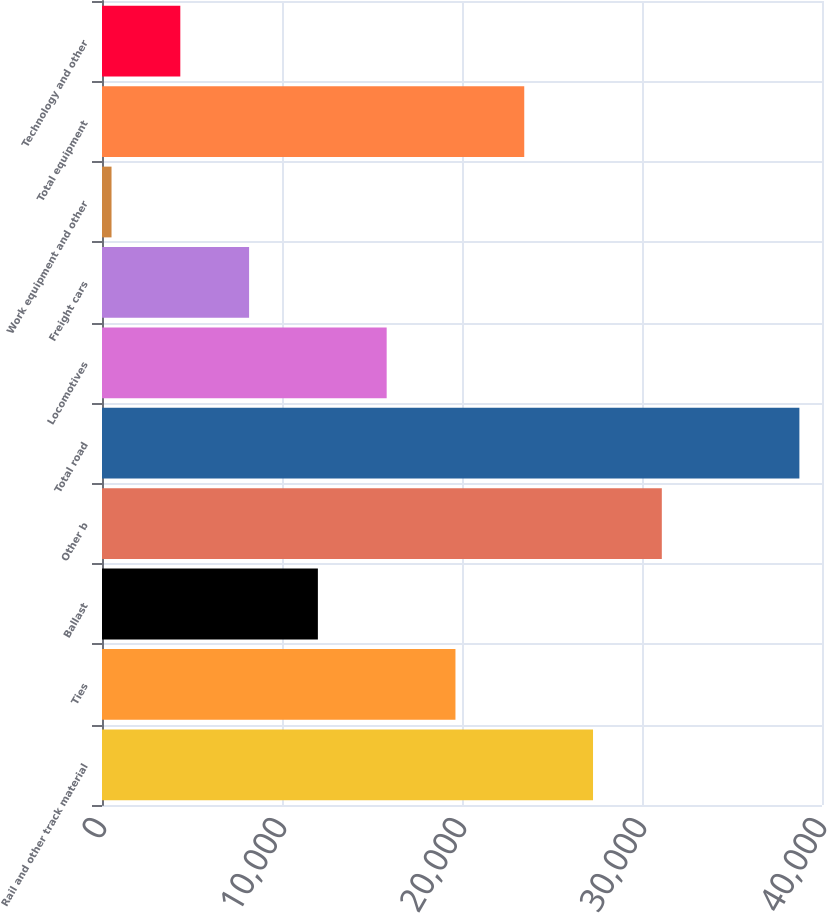<chart> <loc_0><loc_0><loc_500><loc_500><bar_chart><fcel>Rail and other track material<fcel>Ties<fcel>Ballast<fcel>Other b<fcel>Total road<fcel>Locomotives<fcel>Freight cars<fcel>Work equipment and other<fcel>Total equipment<fcel>Technology and other<nl><fcel>27279.5<fcel>19636.5<fcel>11993.5<fcel>31101<fcel>38744<fcel>15815<fcel>8172<fcel>529<fcel>23458<fcel>4350.5<nl></chart> 